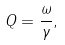Convert formula to latex. <formula><loc_0><loc_0><loc_500><loc_500>Q = \frac { \omega } { \gamma } ,</formula> 